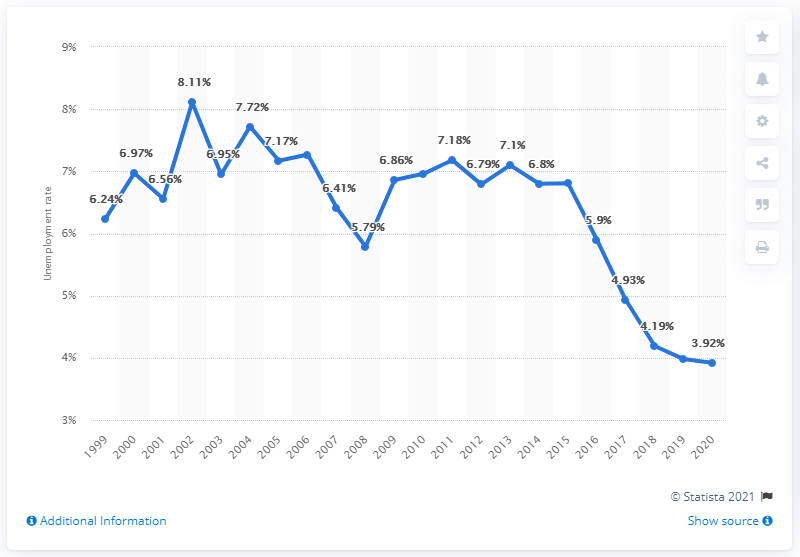Give some essential details in this illustration. According to data from 2020, the unemployment rate in Romania was 3.92%. 